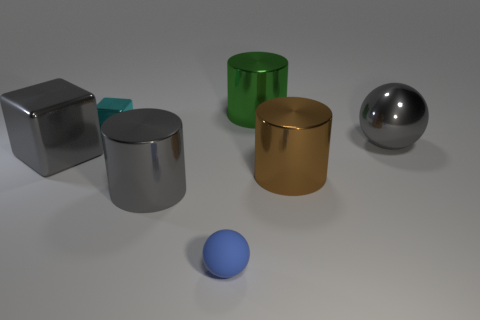Subtract all spheres. How many objects are left? 5 Add 2 matte cylinders. How many objects exist? 9 Add 2 small spheres. How many small spheres are left? 3 Add 1 cyan objects. How many cyan objects exist? 2 Subtract 1 gray balls. How many objects are left? 6 Subtract all small metallic cubes. Subtract all tiny rubber balls. How many objects are left? 5 